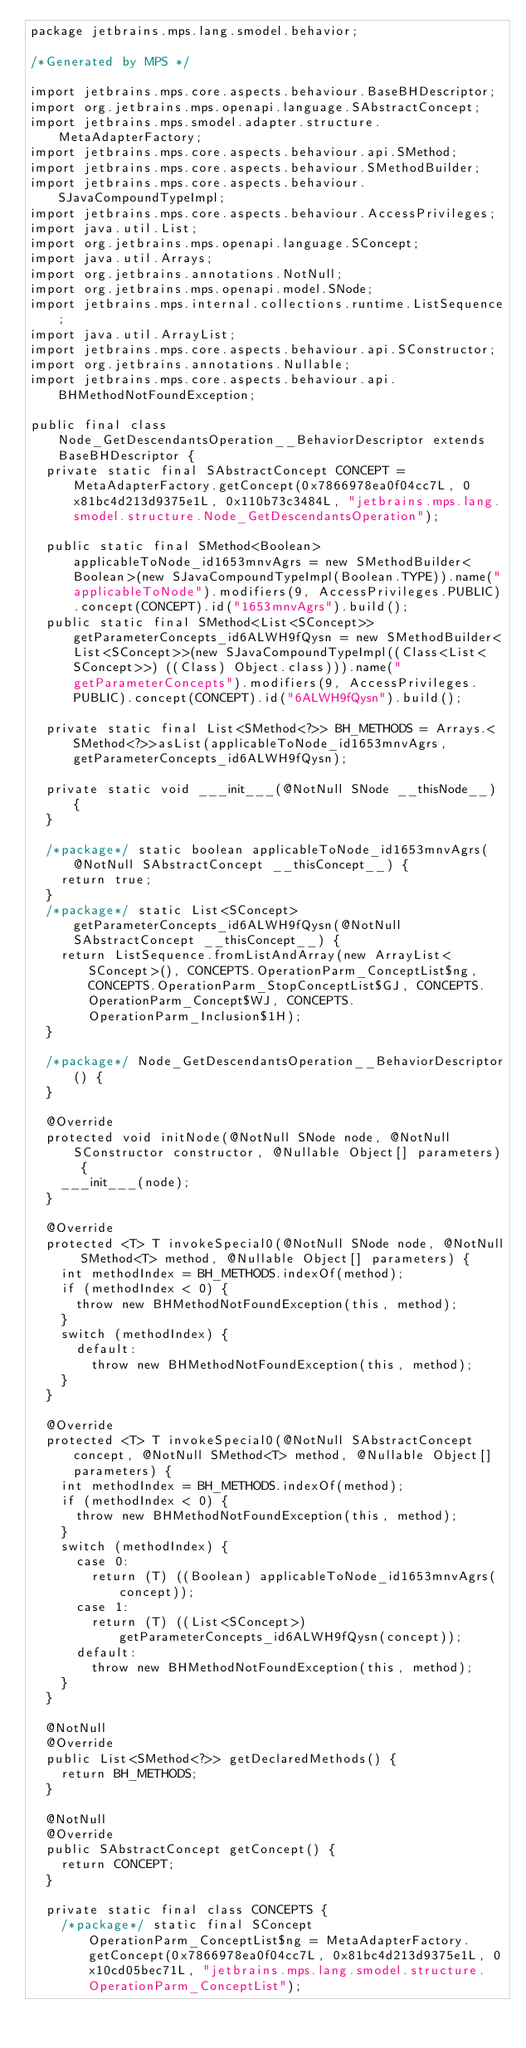Convert code to text. <code><loc_0><loc_0><loc_500><loc_500><_Java_>package jetbrains.mps.lang.smodel.behavior;

/*Generated by MPS */

import jetbrains.mps.core.aspects.behaviour.BaseBHDescriptor;
import org.jetbrains.mps.openapi.language.SAbstractConcept;
import jetbrains.mps.smodel.adapter.structure.MetaAdapterFactory;
import jetbrains.mps.core.aspects.behaviour.api.SMethod;
import jetbrains.mps.core.aspects.behaviour.SMethodBuilder;
import jetbrains.mps.core.aspects.behaviour.SJavaCompoundTypeImpl;
import jetbrains.mps.core.aspects.behaviour.AccessPrivileges;
import java.util.List;
import org.jetbrains.mps.openapi.language.SConcept;
import java.util.Arrays;
import org.jetbrains.annotations.NotNull;
import org.jetbrains.mps.openapi.model.SNode;
import jetbrains.mps.internal.collections.runtime.ListSequence;
import java.util.ArrayList;
import jetbrains.mps.core.aspects.behaviour.api.SConstructor;
import org.jetbrains.annotations.Nullable;
import jetbrains.mps.core.aspects.behaviour.api.BHMethodNotFoundException;

public final class Node_GetDescendantsOperation__BehaviorDescriptor extends BaseBHDescriptor {
  private static final SAbstractConcept CONCEPT = MetaAdapterFactory.getConcept(0x7866978ea0f04cc7L, 0x81bc4d213d9375e1L, 0x110b73c3484L, "jetbrains.mps.lang.smodel.structure.Node_GetDescendantsOperation");

  public static final SMethod<Boolean> applicableToNode_id1653mnvAgrs = new SMethodBuilder<Boolean>(new SJavaCompoundTypeImpl(Boolean.TYPE)).name("applicableToNode").modifiers(9, AccessPrivileges.PUBLIC).concept(CONCEPT).id("1653mnvAgrs").build();
  public static final SMethod<List<SConcept>> getParameterConcepts_id6ALWH9fQysn = new SMethodBuilder<List<SConcept>>(new SJavaCompoundTypeImpl((Class<List<SConcept>>) ((Class) Object.class))).name("getParameterConcepts").modifiers(9, AccessPrivileges.PUBLIC).concept(CONCEPT).id("6ALWH9fQysn").build();

  private static final List<SMethod<?>> BH_METHODS = Arrays.<SMethod<?>>asList(applicableToNode_id1653mnvAgrs, getParameterConcepts_id6ALWH9fQysn);

  private static void ___init___(@NotNull SNode __thisNode__) {
  }

  /*package*/ static boolean applicableToNode_id1653mnvAgrs(@NotNull SAbstractConcept __thisConcept__) {
    return true;
  }
  /*package*/ static List<SConcept> getParameterConcepts_id6ALWH9fQysn(@NotNull SAbstractConcept __thisConcept__) {
    return ListSequence.fromListAndArray(new ArrayList<SConcept>(), CONCEPTS.OperationParm_ConceptList$ng, CONCEPTS.OperationParm_StopConceptList$GJ, CONCEPTS.OperationParm_Concept$WJ, CONCEPTS.OperationParm_Inclusion$1H);
  }

  /*package*/ Node_GetDescendantsOperation__BehaviorDescriptor() {
  }

  @Override
  protected void initNode(@NotNull SNode node, @NotNull SConstructor constructor, @Nullable Object[] parameters) {
    ___init___(node);
  }

  @Override
  protected <T> T invokeSpecial0(@NotNull SNode node, @NotNull SMethod<T> method, @Nullable Object[] parameters) {
    int methodIndex = BH_METHODS.indexOf(method);
    if (methodIndex < 0) {
      throw new BHMethodNotFoundException(this, method);
    }
    switch (methodIndex) {
      default:
        throw new BHMethodNotFoundException(this, method);
    }
  }

  @Override
  protected <T> T invokeSpecial0(@NotNull SAbstractConcept concept, @NotNull SMethod<T> method, @Nullable Object[] parameters) {
    int methodIndex = BH_METHODS.indexOf(method);
    if (methodIndex < 0) {
      throw new BHMethodNotFoundException(this, method);
    }
    switch (methodIndex) {
      case 0:
        return (T) ((Boolean) applicableToNode_id1653mnvAgrs(concept));
      case 1:
        return (T) ((List<SConcept>) getParameterConcepts_id6ALWH9fQysn(concept));
      default:
        throw new BHMethodNotFoundException(this, method);
    }
  }

  @NotNull
  @Override
  public List<SMethod<?>> getDeclaredMethods() {
    return BH_METHODS;
  }

  @NotNull
  @Override
  public SAbstractConcept getConcept() {
    return CONCEPT;
  }

  private static final class CONCEPTS {
    /*package*/ static final SConcept OperationParm_ConceptList$ng = MetaAdapterFactory.getConcept(0x7866978ea0f04cc7L, 0x81bc4d213d9375e1L, 0x10cd05bec71L, "jetbrains.mps.lang.smodel.structure.OperationParm_ConceptList");</code> 